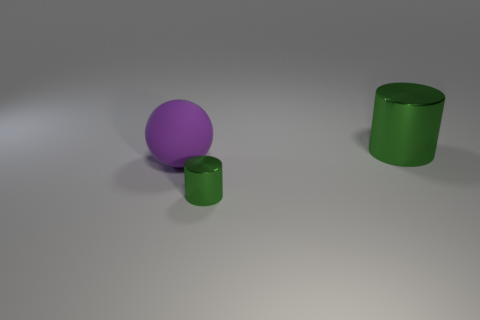Add 3 big purple matte spheres. How many objects exist? 6 Subtract all spheres. How many objects are left? 2 Subtract 2 cylinders. How many cylinders are left? 0 Subtract 1 purple spheres. How many objects are left? 2 Subtract all purple cylinders. Subtract all green blocks. How many cylinders are left? 2 Subtract all tiny metal objects. Subtract all cyan matte objects. How many objects are left? 2 Add 1 green objects. How many green objects are left? 3 Add 2 red rubber cylinders. How many red rubber cylinders exist? 2 